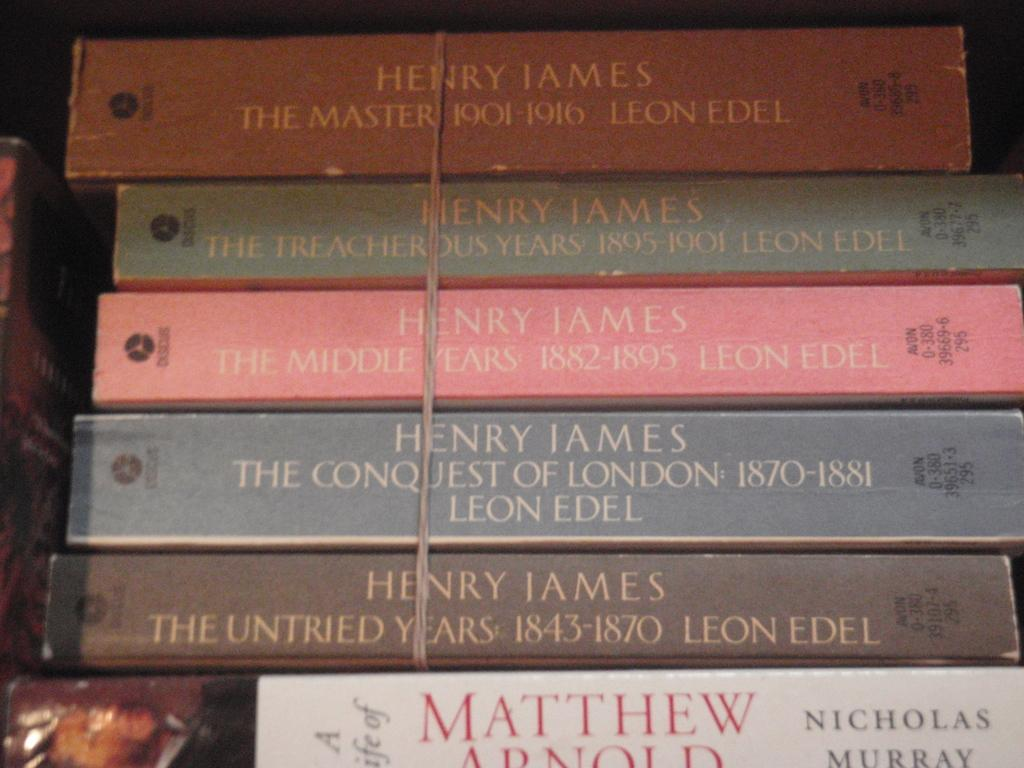<image>
Describe the image concisely. Several Henry James books are stacked up and tied together. 